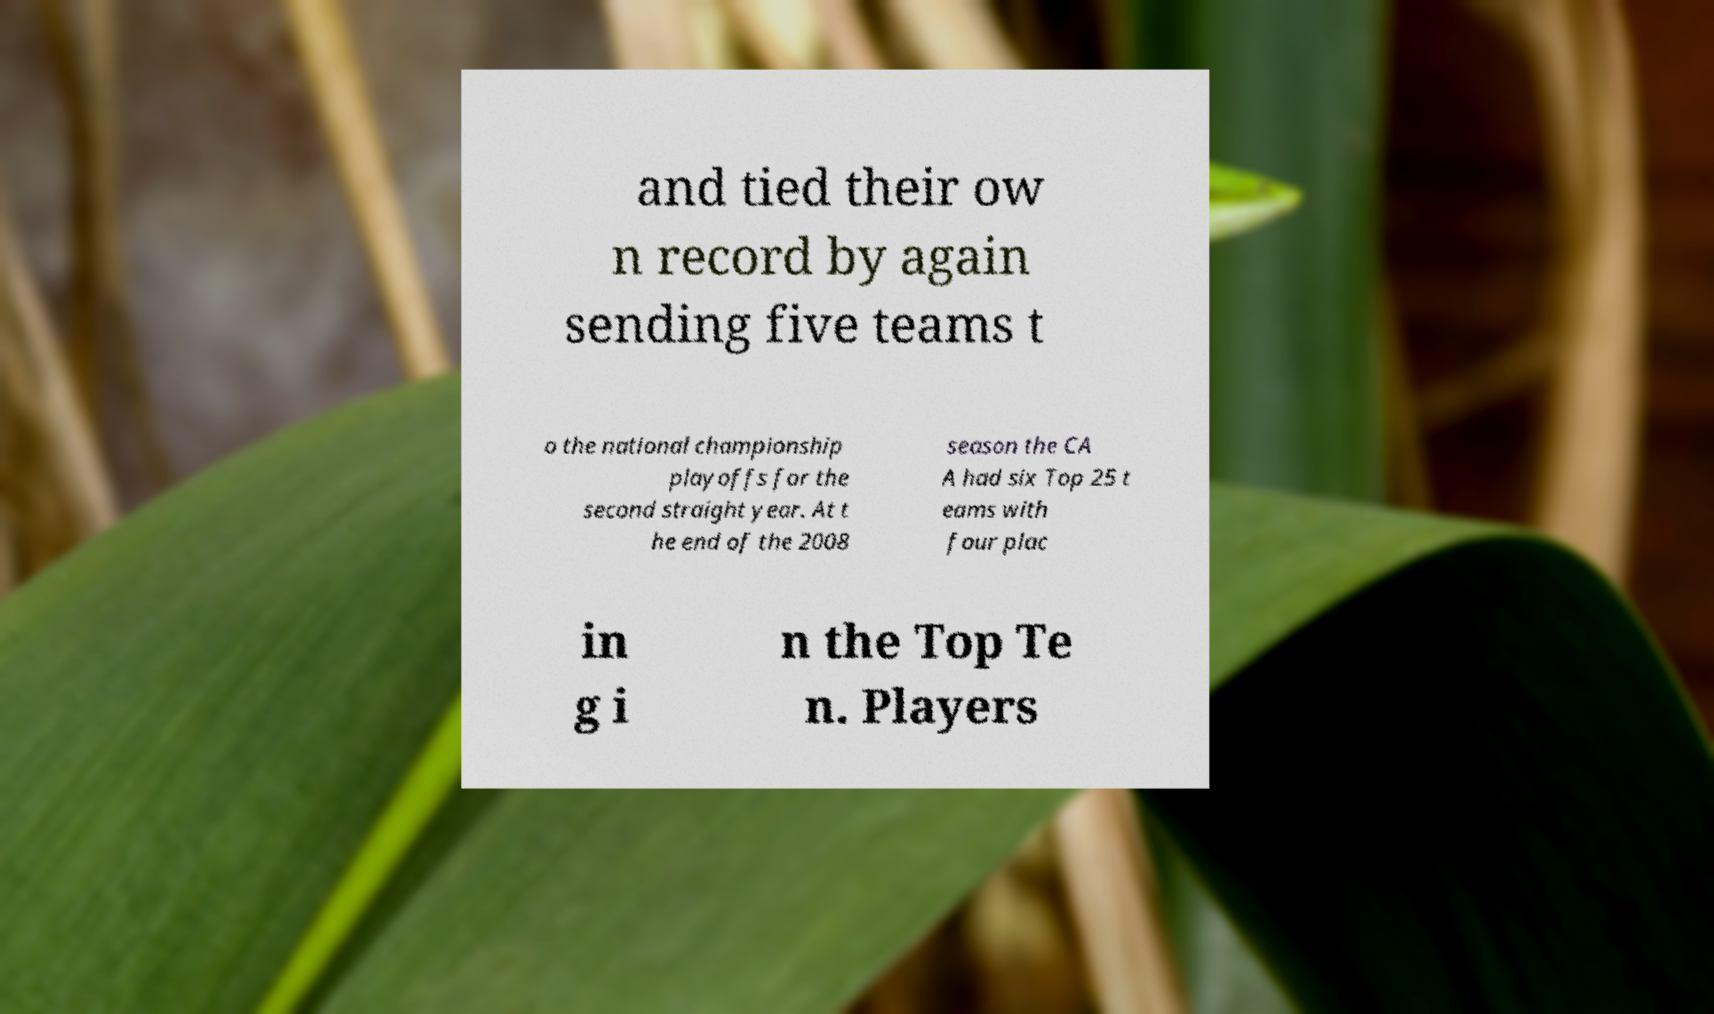Please identify and transcribe the text found in this image. and tied their ow n record by again sending five teams t o the national championship playoffs for the second straight year. At t he end of the 2008 season the CA A had six Top 25 t eams with four plac in g i n the Top Te n. Players 